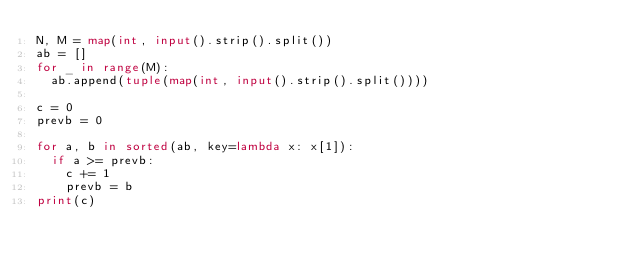<code> <loc_0><loc_0><loc_500><loc_500><_Python_>N, M = map(int, input().strip().split())
ab = []
for _ in range(M):
  ab.append(tuple(map(int, input().strip().split())))

c = 0
prevb = 0

for a, b in sorted(ab, key=lambda x: x[1]):
  if a >= prevb:
    c += 1
    prevb = b
print(c)</code> 